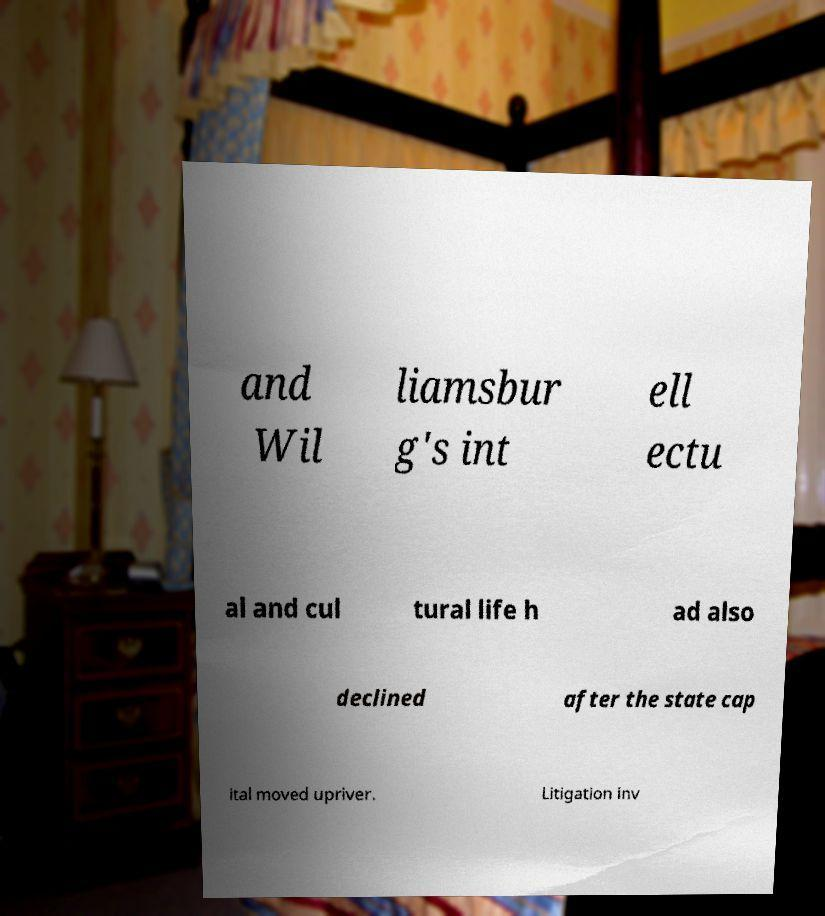There's text embedded in this image that I need extracted. Can you transcribe it verbatim? and Wil liamsbur g's int ell ectu al and cul tural life h ad also declined after the state cap ital moved upriver. Litigation inv 